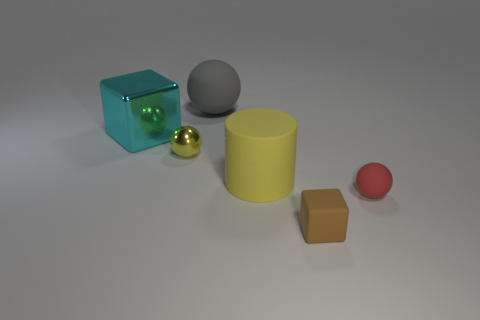How many red rubber things are there?
Ensure brevity in your answer.  1. Is the number of yellow metallic balls that are to the right of the tiny brown object greater than the number of red rubber objects?
Ensure brevity in your answer.  No. There is a brown thing in front of the metal sphere; what is it made of?
Your answer should be compact. Rubber. What is the color of the other tiny thing that is the same shape as the yellow metal object?
Make the answer very short. Red. What number of tiny shiny spheres have the same color as the big rubber cylinder?
Make the answer very short. 1. There is a ball that is to the right of the cylinder; is its size the same as the cyan shiny cube that is in front of the gray rubber object?
Your answer should be very brief. No. Is the size of the metal cube the same as the rubber sphere behind the large block?
Ensure brevity in your answer.  Yes. What size is the red thing?
Your answer should be very brief. Small. There is a small thing that is the same material as the big cyan thing; what color is it?
Provide a short and direct response. Yellow. What number of large cyan things are the same material as the big cube?
Keep it short and to the point. 0. 